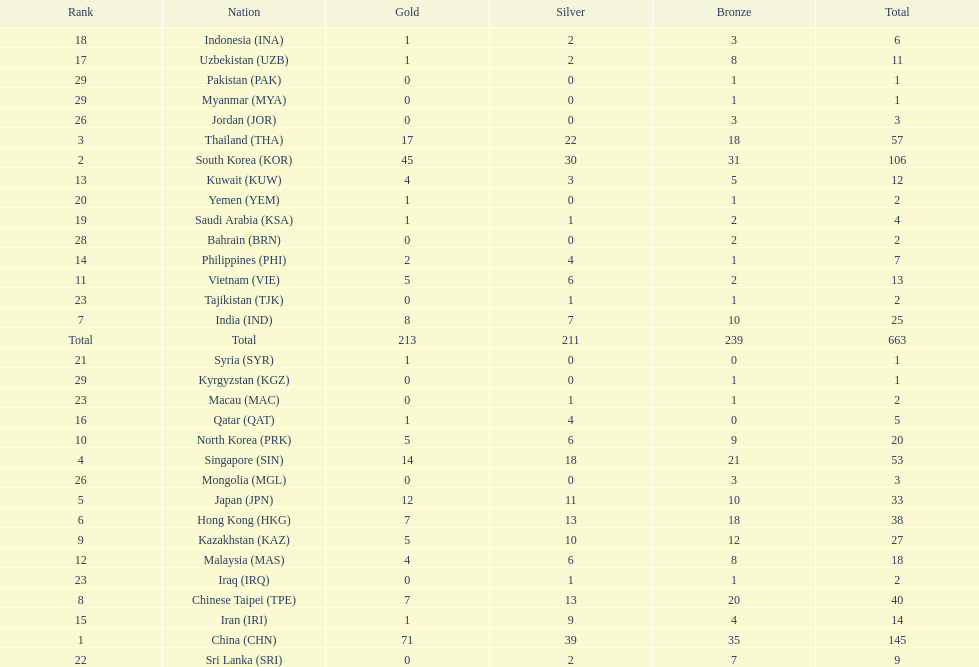Can you give me this table as a dict? {'header': ['Rank', 'Nation', 'Gold', 'Silver', 'Bronze', 'Total'], 'rows': [['18', 'Indonesia\xa0(INA)', '1', '2', '3', '6'], ['17', 'Uzbekistan\xa0(UZB)', '1', '2', '8', '11'], ['29', 'Pakistan\xa0(PAK)', '0', '0', '1', '1'], ['29', 'Myanmar\xa0(MYA)', '0', '0', '1', '1'], ['26', 'Jordan\xa0(JOR)', '0', '0', '3', '3'], ['3', 'Thailand\xa0(THA)', '17', '22', '18', '57'], ['2', 'South Korea\xa0(KOR)', '45', '30', '31', '106'], ['13', 'Kuwait\xa0(KUW)', '4', '3', '5', '12'], ['20', 'Yemen\xa0(YEM)', '1', '0', '1', '2'], ['19', 'Saudi Arabia\xa0(KSA)', '1', '1', '2', '4'], ['28', 'Bahrain\xa0(BRN)', '0', '0', '2', '2'], ['14', 'Philippines\xa0(PHI)', '2', '4', '1', '7'], ['11', 'Vietnam\xa0(VIE)', '5', '6', '2', '13'], ['23', 'Tajikistan\xa0(TJK)', '0', '1', '1', '2'], ['7', 'India\xa0(IND)', '8', '7', '10', '25'], ['Total', 'Total', '213', '211', '239', '663'], ['21', 'Syria\xa0(SYR)', '1', '0', '0', '1'], ['29', 'Kyrgyzstan\xa0(KGZ)', '0', '0', '1', '1'], ['23', 'Macau\xa0(MAC)', '0', '1', '1', '2'], ['16', 'Qatar\xa0(QAT)', '1', '4', '0', '5'], ['10', 'North Korea\xa0(PRK)', '5', '6', '9', '20'], ['4', 'Singapore\xa0(SIN)', '14', '18', '21', '53'], ['26', 'Mongolia\xa0(MGL)', '0', '0', '3', '3'], ['5', 'Japan\xa0(JPN)', '12', '11', '10', '33'], ['6', 'Hong Kong\xa0(HKG)', '7', '13', '18', '38'], ['9', 'Kazakhstan\xa0(KAZ)', '5', '10', '12', '27'], ['12', 'Malaysia\xa0(MAS)', '4', '6', '8', '18'], ['23', 'Iraq\xa0(IRQ)', '0', '1', '1', '2'], ['8', 'Chinese Taipei\xa0(TPE)', '7', '13', '20', '40'], ['15', 'Iran\xa0(IRI)', '1', '9', '4', '14'], ['1', 'China\xa0(CHN)', '71', '39', '35', '145'], ['22', 'Sri Lanka\xa0(SRI)', '0', '2', '7', '9']]} What is the total number of medals that india won in the asian youth games? 25. 